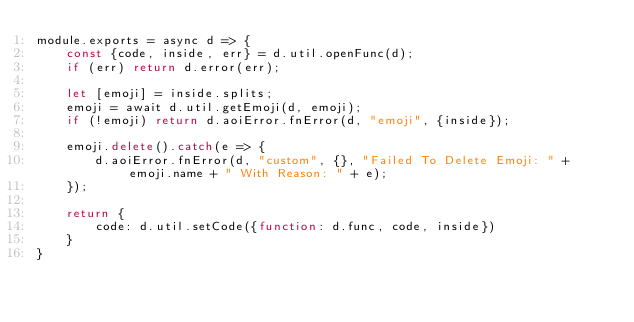<code> <loc_0><loc_0><loc_500><loc_500><_JavaScript_>module.exports = async d => {
    const {code, inside, err} = d.util.openFunc(d);
    if (err) return d.error(err);

    let [emoji] = inside.splits;
    emoji = await d.util.getEmoji(d, emoji);
    if (!emoji) return d.aoiError.fnError(d, "emoji", {inside});

    emoji.delete().catch(e => {
        d.aoiError.fnError(d, "custom", {}, "Failed To Delete Emoji: " + emoji.name + " With Reason: " + e);
    });

    return {
        code: d.util.setCode({function: d.func, code, inside})
    }
}</code> 